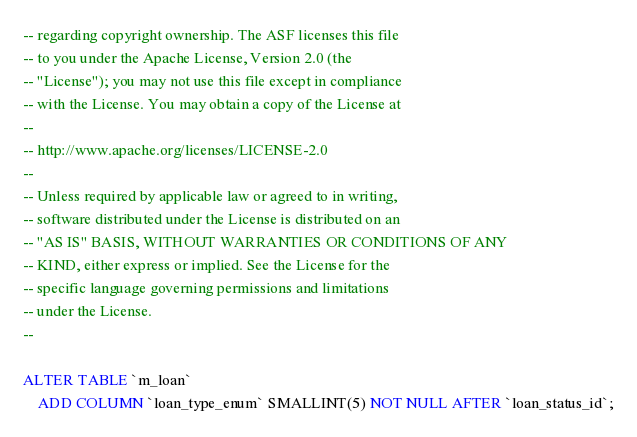Convert code to text. <code><loc_0><loc_0><loc_500><loc_500><_SQL_>-- regarding copyright ownership. The ASF licenses this file
-- to you under the Apache License, Version 2.0 (the
-- "License"); you may not use this file except in compliance
-- with the License. You may obtain a copy of the License at
--
-- http://www.apache.org/licenses/LICENSE-2.0
--
-- Unless required by applicable law or agreed to in writing,
-- software distributed under the License is distributed on an
-- "AS IS" BASIS, WITHOUT WARRANTIES OR CONDITIONS OF ANY
-- KIND, either express or implied. See the License for the
-- specific language governing permissions and limitations
-- under the License.
--

ALTER TABLE `m_loan`
	ADD COLUMN `loan_type_enum` SMALLINT(5) NOT NULL AFTER `loan_status_id`;</code> 